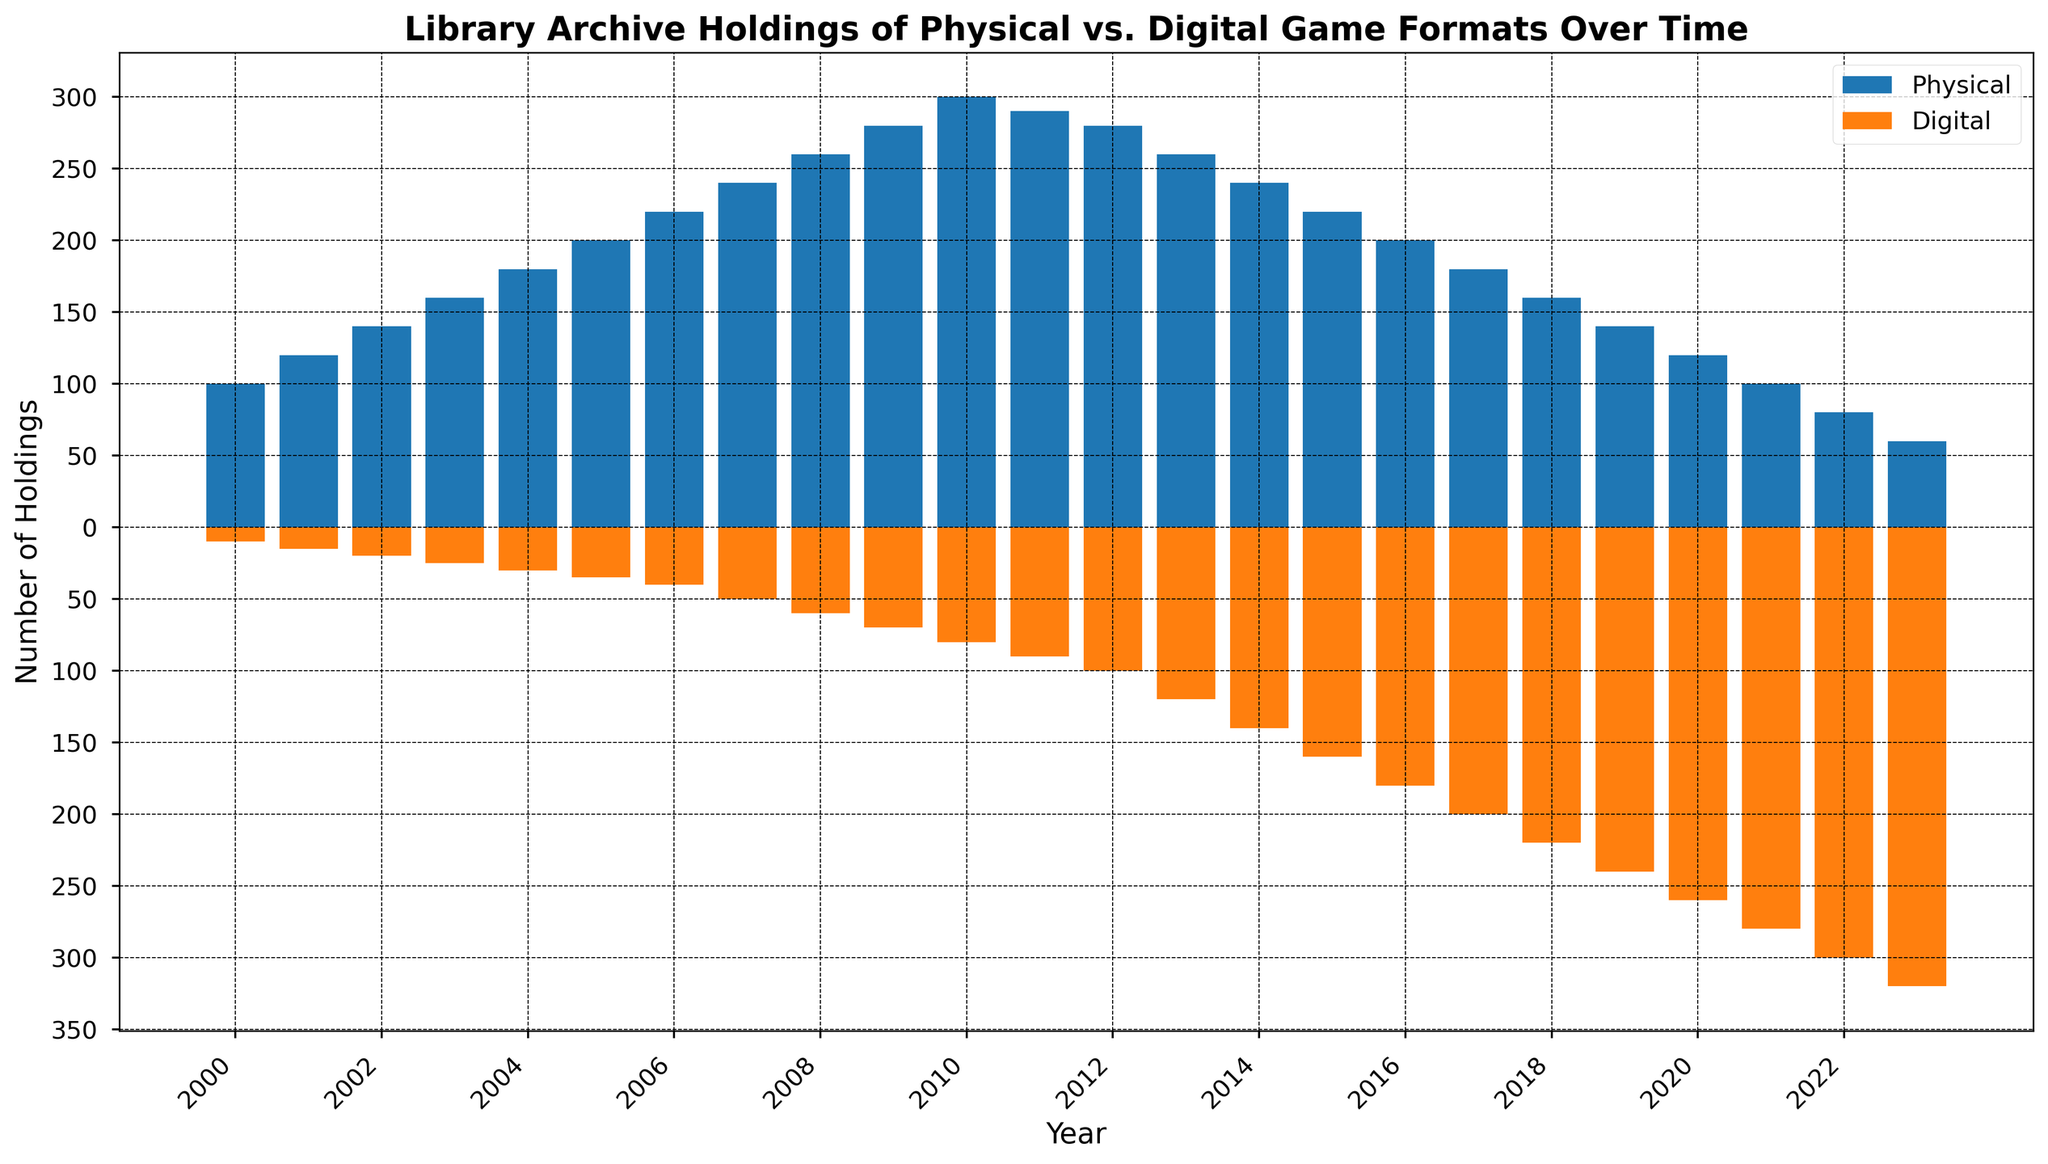What is the total number of physical holdings in 2003? To find the total number of physical holdings in 2003, look at the height of the blue bar corresponding to that year. The value is 160.
Answer: 160 Which year has the highest number of digital holdings? The orange bars represent digital holdings. The highest bar indicates the year 2023 with 320 holdings.
Answer: 2023 What is the difference between physical and digital holdings in 2005? For 2005, the physical holdings are 200, and digital holdings are 35. The difference is calculated as 200 - 35 = 165.
Answer: 165 In what year did digital holdings begin to exceed 100? By examining the orange bars, digital holdings exceed 100 in 2012.
Answer: 2012 Which year saw the highest number of total holdings (physical plus digital)? Add the values of the blue and the orange bars for each year and compare. The highest combined value is in 2010 with physical holdings of 300 and digital holdings of 80, summing up to 380.
Answer: 2010 How many years have physical holdings of 200 or more? The physical holdings exceed or equal 200 from years 2005 to 2010, totaling 6 years.
Answer: 6 What is the trend observed in physical holdings from 2010 to 2023? Observe the blue bars from 2010 to 2023. They show a downward trend from 300 to 60.
Answer: Downward trend Compare the number of physical and digital holdings in the year 2015. Which is greater? In 2015, the physical holdings are 220, and the digital holdings are 160. Physical holdings are greater.
Answer: Physical holdings What is the combined total of physical holdings for the years 2000 and 2023? Sum the physical holdings for 2000 (100) and 2023 (60). The total is 100 + 60 = 160.
Answer: 160 In which two consecutive years is the decrease in physical holdings the highest? By inspecting the height difference of blue bars for all consecutive years, the steepest decline occurs between 2010 (300) and 2011 (290). The difference is 300 - 290 = 10, which is not the highest. For 2011 (290) to 2012 (280), the difference is 10. For 2021 (100) to 2022 (80), the difference is 20. The highest decrease happens between 2021 and 2022 with a difference of 20.
Answer: 2021 and 2022 